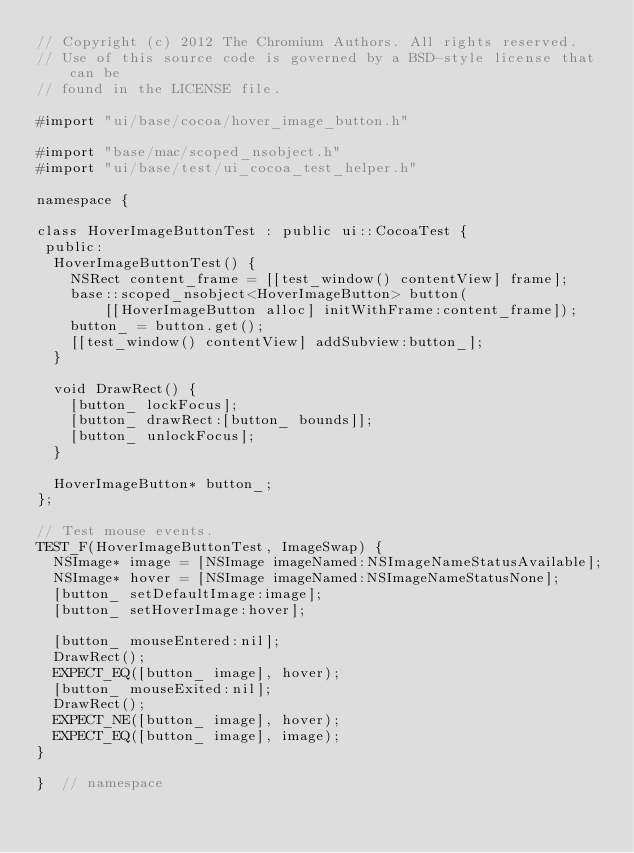Convert code to text. <code><loc_0><loc_0><loc_500><loc_500><_ObjectiveC_>// Copyright (c) 2012 The Chromium Authors. All rights reserved.
// Use of this source code is governed by a BSD-style license that can be
// found in the LICENSE file.

#import "ui/base/cocoa/hover_image_button.h"

#import "base/mac/scoped_nsobject.h"
#import "ui/base/test/ui_cocoa_test_helper.h"

namespace {

class HoverImageButtonTest : public ui::CocoaTest {
 public:
  HoverImageButtonTest() {
    NSRect content_frame = [[test_window() contentView] frame];
    base::scoped_nsobject<HoverImageButton> button(
        [[HoverImageButton alloc] initWithFrame:content_frame]);
    button_ = button.get();
    [[test_window() contentView] addSubview:button_];
  }

  void DrawRect() {
    [button_ lockFocus];
    [button_ drawRect:[button_ bounds]];
    [button_ unlockFocus];
  }

  HoverImageButton* button_;
};

// Test mouse events.
TEST_F(HoverImageButtonTest, ImageSwap) {
  NSImage* image = [NSImage imageNamed:NSImageNameStatusAvailable];
  NSImage* hover = [NSImage imageNamed:NSImageNameStatusNone];
  [button_ setDefaultImage:image];
  [button_ setHoverImage:hover];

  [button_ mouseEntered:nil];
  DrawRect();
  EXPECT_EQ([button_ image], hover);
  [button_ mouseExited:nil];
  DrawRect();
  EXPECT_NE([button_ image], hover);
  EXPECT_EQ([button_ image], image);
}

}  // namespace
</code> 